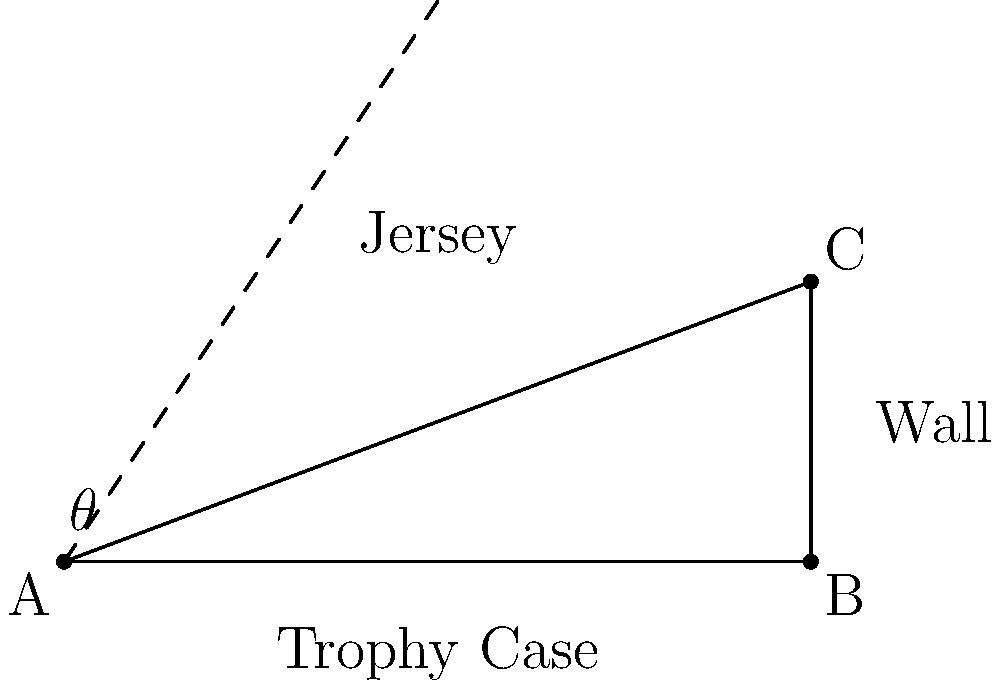You want to display your prized San Jose Sharks jersey in a trophy case for optimal viewing. The trophy case is 8 feet wide and 3 feet high. If you want visitors to see the jersey at a 45-degree angle when standing at point A, what should be the angle of elevation ($\theta$) between the bottom of the case and the jersey? Let's approach this step-by-step:

1) We have a right triangle ABC, where:
   AB = 8 feet (width of the trophy case)
   BC = 3 feet (height of the trophy case)

2) We want the line of sight from A to the jersey to be at a 45-degree angle.

3) The line of sight will form the hypotenuse of the right triangle.

4) In a 45-45-90 triangle, the two legs are equal. So, the height of the point where the line of sight hits the wall should be equal to the width of the case.

5) Therefore, the point where the line of sight hits the wall is 8 feet high from point A.

6) Now we have a new right triangle:
   Base = 8 feet
   Height = 8 feet (total) - 3 feet (case height) = 5 feet

7) We can find $\theta$ using the tangent function:

   $$\tan(\theta) = \frac{\text{opposite}}{\text{adjacent}} = \frac{5}{8}$$

8) To solve for $\theta$:

   $$\theta = \arctan(\frac{5}{8})$$

9) Calculate:
   $$\theta \approx 32.0053°$$
Answer: $32.0053°$ 